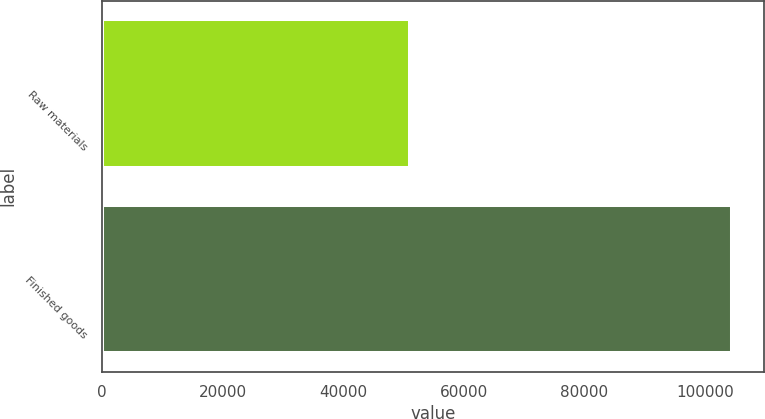Convert chart. <chart><loc_0><loc_0><loc_500><loc_500><bar_chart><fcel>Raw materials<fcel>Finished goods<nl><fcel>51103<fcel>104510<nl></chart> 